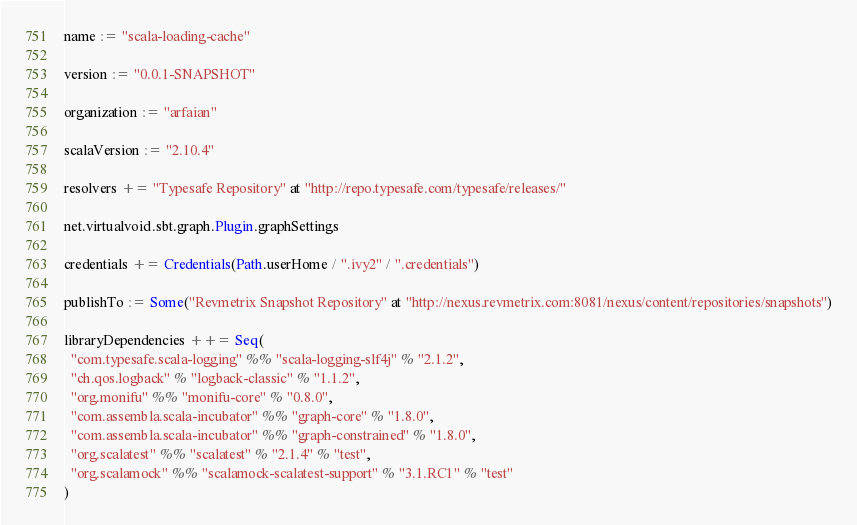Convert code to text. <code><loc_0><loc_0><loc_500><loc_500><_Scala_>name := "scala-loading-cache"

version := "0.0.1-SNAPSHOT"

organization := "arfaian"

scalaVersion := "2.10.4"

resolvers += "Typesafe Repository" at "http://repo.typesafe.com/typesafe/releases/"

net.virtualvoid.sbt.graph.Plugin.graphSettings

credentials += Credentials(Path.userHome / ".ivy2" / ".credentials")

publishTo := Some("Revmetrix Snapshot Repository" at "http://nexus.revmetrix.com:8081/nexus/content/repositories/snapshots")

libraryDependencies ++= Seq(
  "com.typesafe.scala-logging" %% "scala-logging-slf4j" % "2.1.2",
  "ch.qos.logback" % "logback-classic" % "1.1.2",
  "org.monifu" %% "monifu-core" % "0.8.0",
  "com.assembla.scala-incubator" %% "graph-core" % "1.8.0",
  "com.assembla.scala-incubator" %% "graph-constrained" % "1.8.0",
  "org.scalatest" %% "scalatest" % "2.1.4" % "test",
  "org.scalamock" %% "scalamock-scalatest-support" % "3.1.RC1" % "test"
)
</code> 